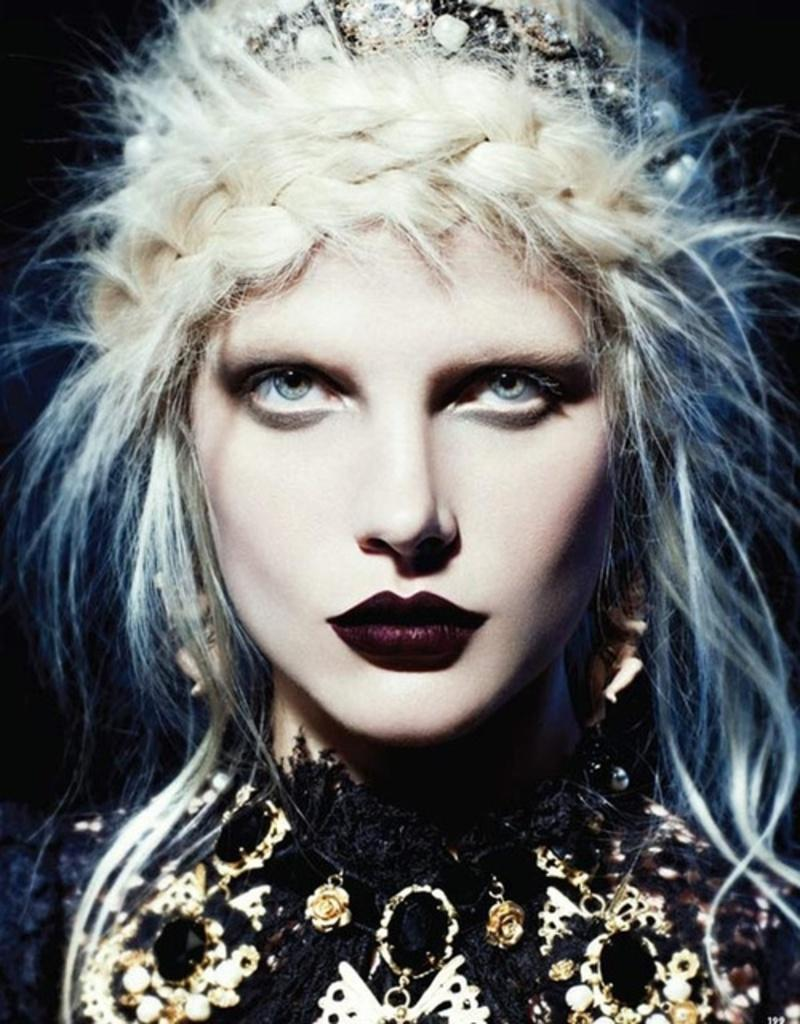Who is the main subject in the image? There is a woman in the image. What is the woman wearing in the image? The woman is wearing a black dress. Are there any accessories visible in the image? Yes, the woman is wearing a hair band. What type of quartz can be seen on the woman's sweater in the image? There is no quartz or sweater present in the image. The woman is wearing a black dress, not a sweater. 